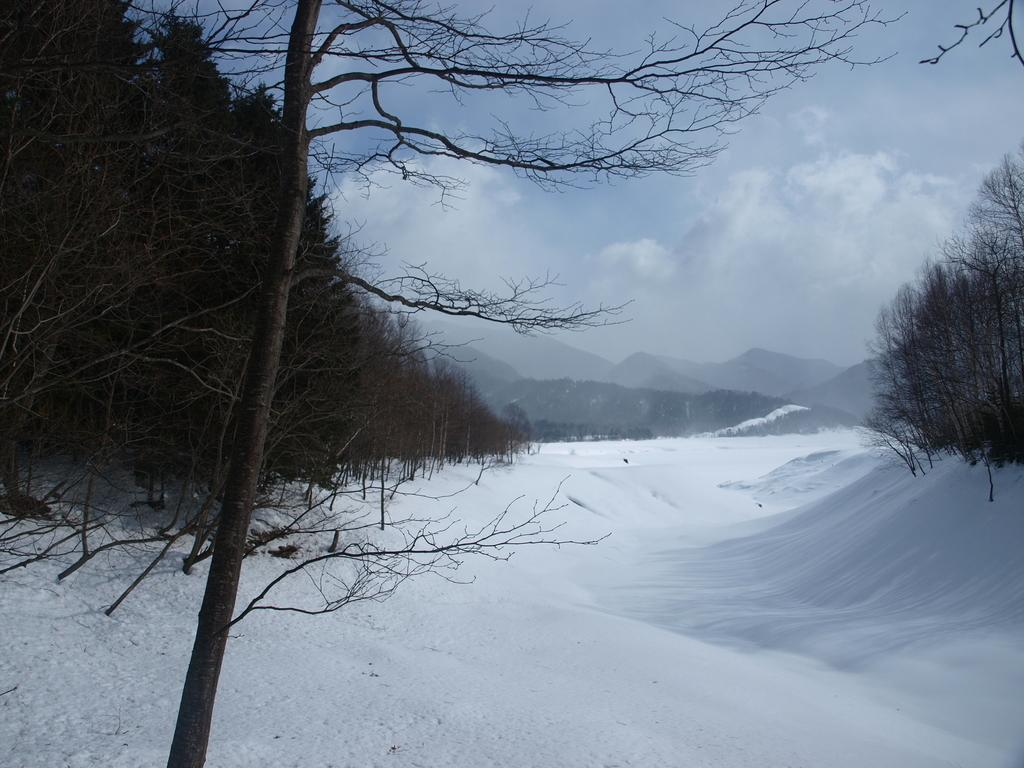What type of natural environment is depicted in the image? The image features many trees, snow, clouds, and mountains, which suggests a winter landscape. Can you describe the ground in the image? The ground in the image is covered with snow. What is visible in the sky at the top of the image? There are clouds in the sky at the top of the image. What type of geographical feature can be seen in the background of the image? There are mountains in the background of the image. What flavor of liquid can be seen dripping from the structure in the image? There is no structure or liquid present in the image; it features a winter landscape with trees, snow, clouds, and mountains. 